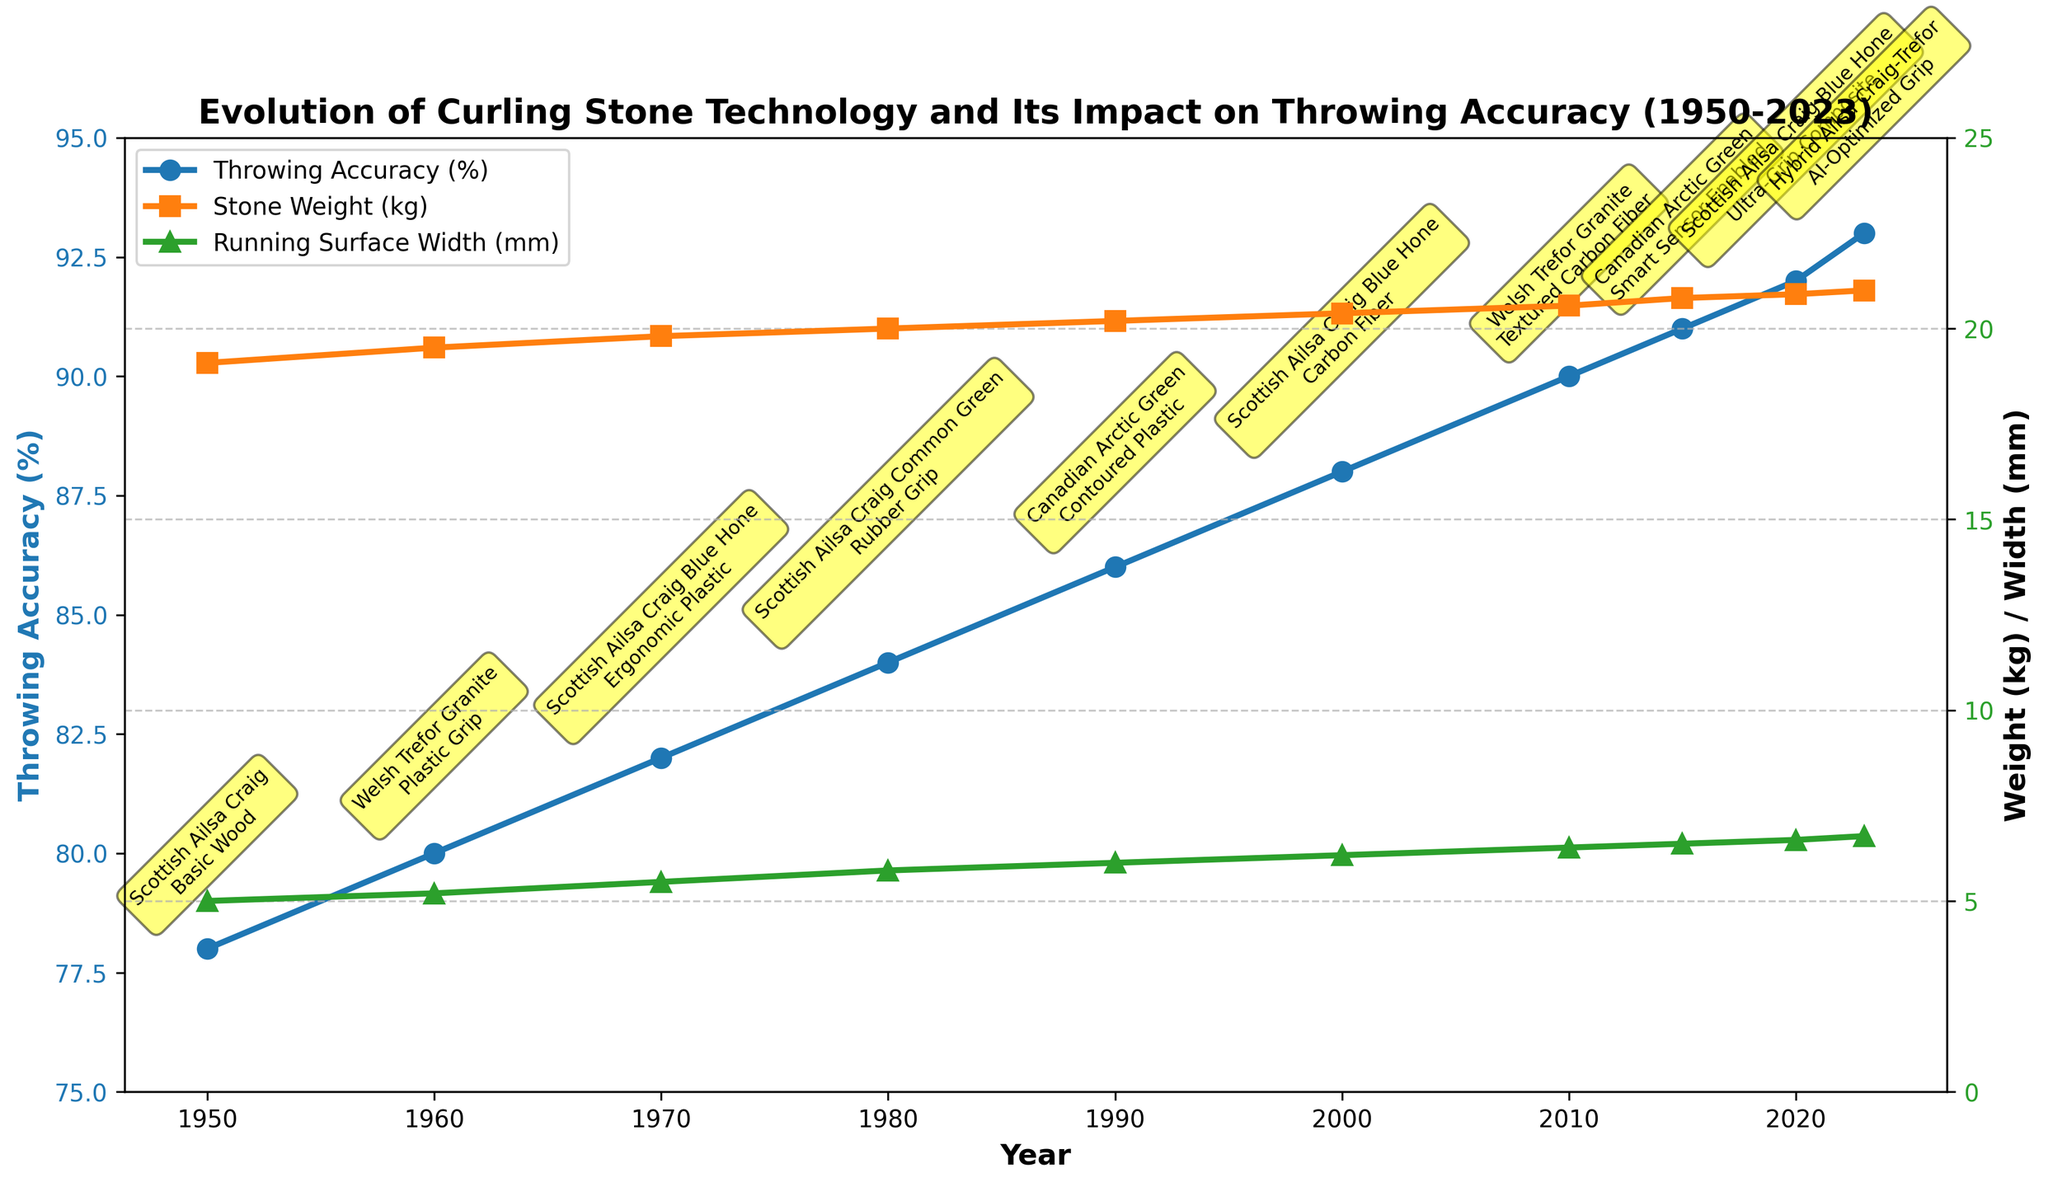What is the trend in throwing accuracy from 1950 to 2023? By observing the blue line that represents Throwing Accuracy (%), we can see a general upward trend from 1950 (78%) to 2023 (93%).
Answer: An upward trend How does the stone weight change over time from 1950 to 2023? Referring to the orange line that represents Stone Weight (kg), it shows a gradual increase from 19.1 kg in 1950 to 21.0 kg in 2023.
Answer: Gradual increase Which year had the largest increase in throwing accuracy compared to the previous decade? By calculating differences for each decade, 2010 had an increase from 90% to 91%, but earlier years show more substantial increases. Specifically, from 1980 to 1990, it increased by 2% (84% to 86%).
Answer: 1980 to 1990 What materials were used in the stone from 2000 to 2010, and how did throwing accuracy change? From 2000 (Scottish Ailsa Craig Blue Hone with Carbon Fiber handle) to 2010 (Welsh Trefor Granite with Textured Carbon Fiber handle), the throwing accuracy increased from 88% to 90%.
Answer: From 88% to 90% Compare the stone weight in 1970 and 2020, and what is the difference? The stone weight was 19.8 kg in 1970 and 20.9 kg in 2020. The difference is 20.9 - 19.8 = 1.1 kg.
Answer: 1.1 kg How did the running surface width evolve from 1980 to 2023? Observing the green line representing Running Surface Width (mm), it increased from 5.8 mm in 1980 to 6.7 mm in 2023.
Answer: Increase from 5.8 mm to 6.7 mm Which handle design corresponds to the highest throwing accuracy in the figure? The AI-Optimized Grip in 2023 corresponds to the highest throwing accuracy of 93%.
Answer: AI-Optimized Grip What is the relationship between the stone material used and the throwing accuracy in 1950 and 2020? In 1950, the stone material was Scottish Ailsa Craig, and throwing accuracy was 78%. In 2020, using the same material (Scottish Ailsa Craig Blue Hone) but with an Ultra-Grip Composite handle, the accuracy increased to 92%.
Answer: Both use Scottish Ailsa Craig, but accuracy increased from 78% to 92% What was the trend in throwing accuracy between Welsh Trefor Granite stones used in 2010 and 1960? In 1960, Welsh Trefor Granite stones had a throwing accuracy of 80%. In 2010, the same material but with Textured Carbon Fiber handle resulted in 90% accuracy, showing an increase.
Answer: Increased from 80% to 90% How has the handle design evolved from 1950 to 2023? Starting with Basic Wood in 1950, it progressed to Plastic Grip in 1960, Ergonomic Plastic in 1970, Rubber Grip in 1980, Contoured Plastic in 1990, Carbon Fiber in 2000, Textured Carbon Fiber in 2010, Smart Sensor-Enabled in 2015, Ultra-Grip Composite in 2020, and AI-Optimized Grip in 2023.
Answer: Evolved from Basic Wood to AI-Optimized Grip 